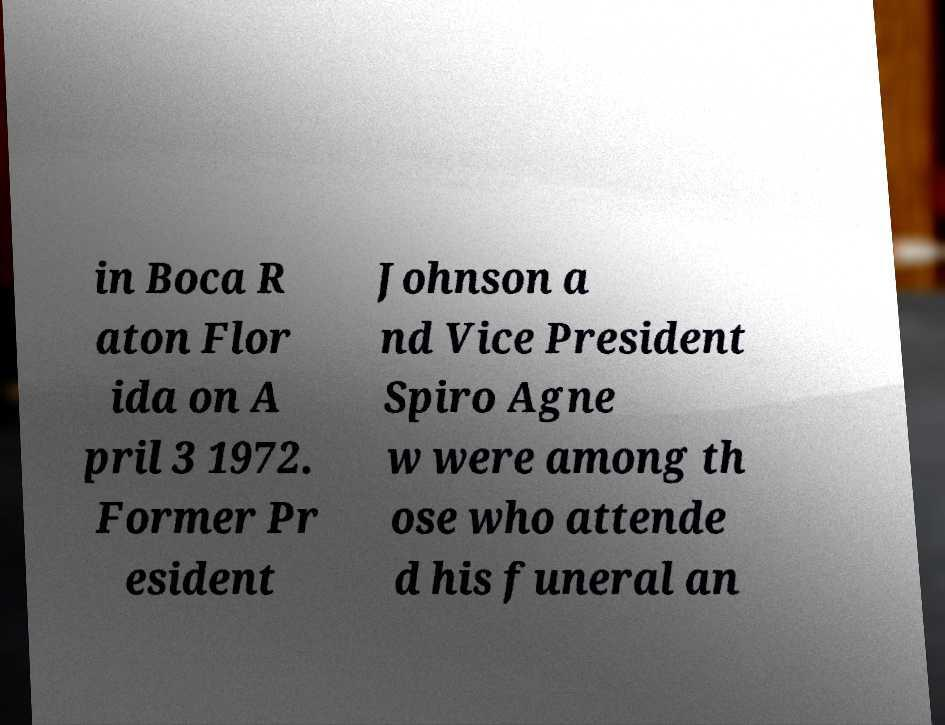Could you extract and type out the text from this image? in Boca R aton Flor ida on A pril 3 1972. Former Pr esident Johnson a nd Vice President Spiro Agne w were among th ose who attende d his funeral an 